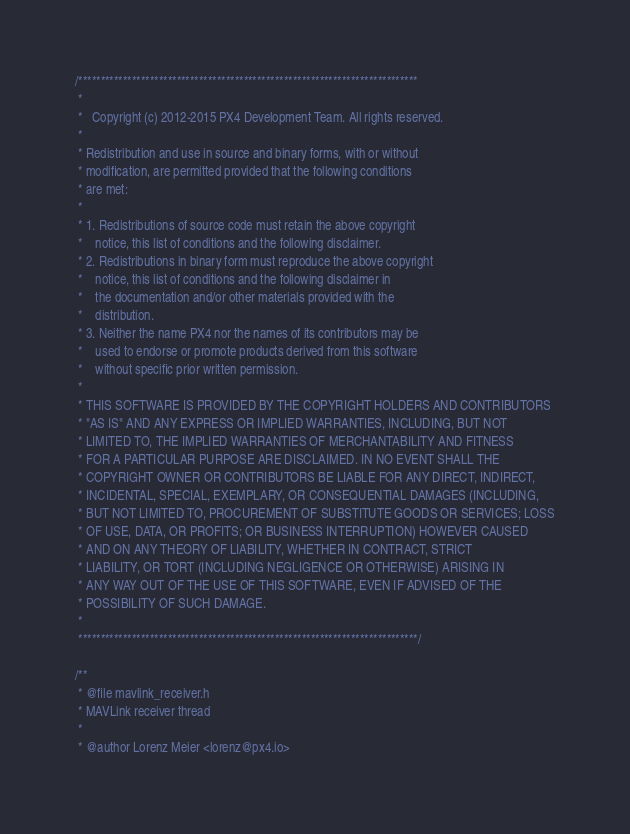Convert code to text. <code><loc_0><loc_0><loc_500><loc_500><_C_>/****************************************************************************
 *
 *   Copyright (c) 2012-2015 PX4 Development Team. All rights reserved.
 *
 * Redistribution and use in source and binary forms, with or without
 * modification, are permitted provided that the following conditions
 * are met:
 *
 * 1. Redistributions of source code must retain the above copyright
 *    notice, this list of conditions and the following disclaimer.
 * 2. Redistributions in binary form must reproduce the above copyright
 *    notice, this list of conditions and the following disclaimer in
 *    the documentation and/or other materials provided with the
 *    distribution.
 * 3. Neither the name PX4 nor the names of its contributors may be
 *    used to endorse or promote products derived from this software
 *    without specific prior written permission.
 *
 * THIS SOFTWARE IS PROVIDED BY THE COPYRIGHT HOLDERS AND CONTRIBUTORS
 * "AS IS" AND ANY EXPRESS OR IMPLIED WARRANTIES, INCLUDING, BUT NOT
 * LIMITED TO, THE IMPLIED WARRANTIES OF MERCHANTABILITY AND FITNESS
 * FOR A PARTICULAR PURPOSE ARE DISCLAIMED. IN NO EVENT SHALL THE
 * COPYRIGHT OWNER OR CONTRIBUTORS BE LIABLE FOR ANY DIRECT, INDIRECT,
 * INCIDENTAL, SPECIAL, EXEMPLARY, OR CONSEQUENTIAL DAMAGES (INCLUDING,
 * BUT NOT LIMITED TO, PROCUREMENT OF SUBSTITUTE GOODS OR SERVICES; LOSS
 * OF USE, DATA, OR PROFITS; OR BUSINESS INTERRUPTION) HOWEVER CAUSED
 * AND ON ANY THEORY OF LIABILITY, WHETHER IN CONTRACT, STRICT
 * LIABILITY, OR TORT (INCLUDING NEGLIGENCE OR OTHERWISE) ARISING IN
 * ANY WAY OUT OF THE USE OF THIS SOFTWARE, EVEN IF ADVISED OF THE
 * POSSIBILITY OF SUCH DAMAGE.
 *
 ****************************************************************************/

/**
 * @file mavlink_receiver.h
 * MAVLink receiver thread
 *
 * @author Lorenz Meier <lorenz@px4.io></code> 